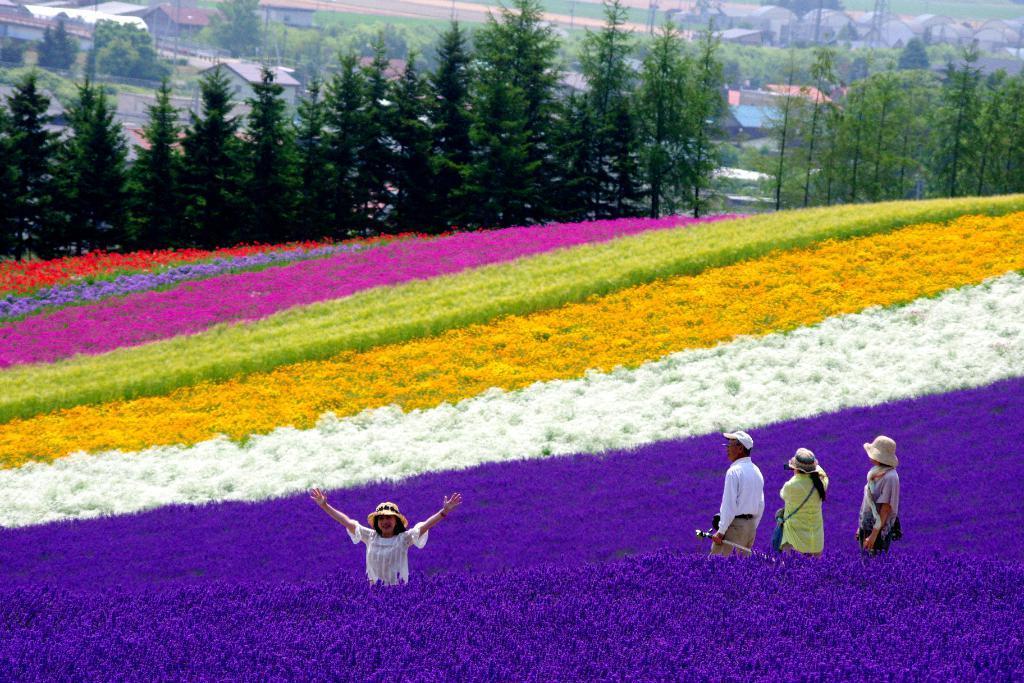Please provide a concise description of this image. In this image we can see some people standing. In the foreground we can see group of flowers on plants. In the background, we can see some buildings, groups of trees and some poles. 